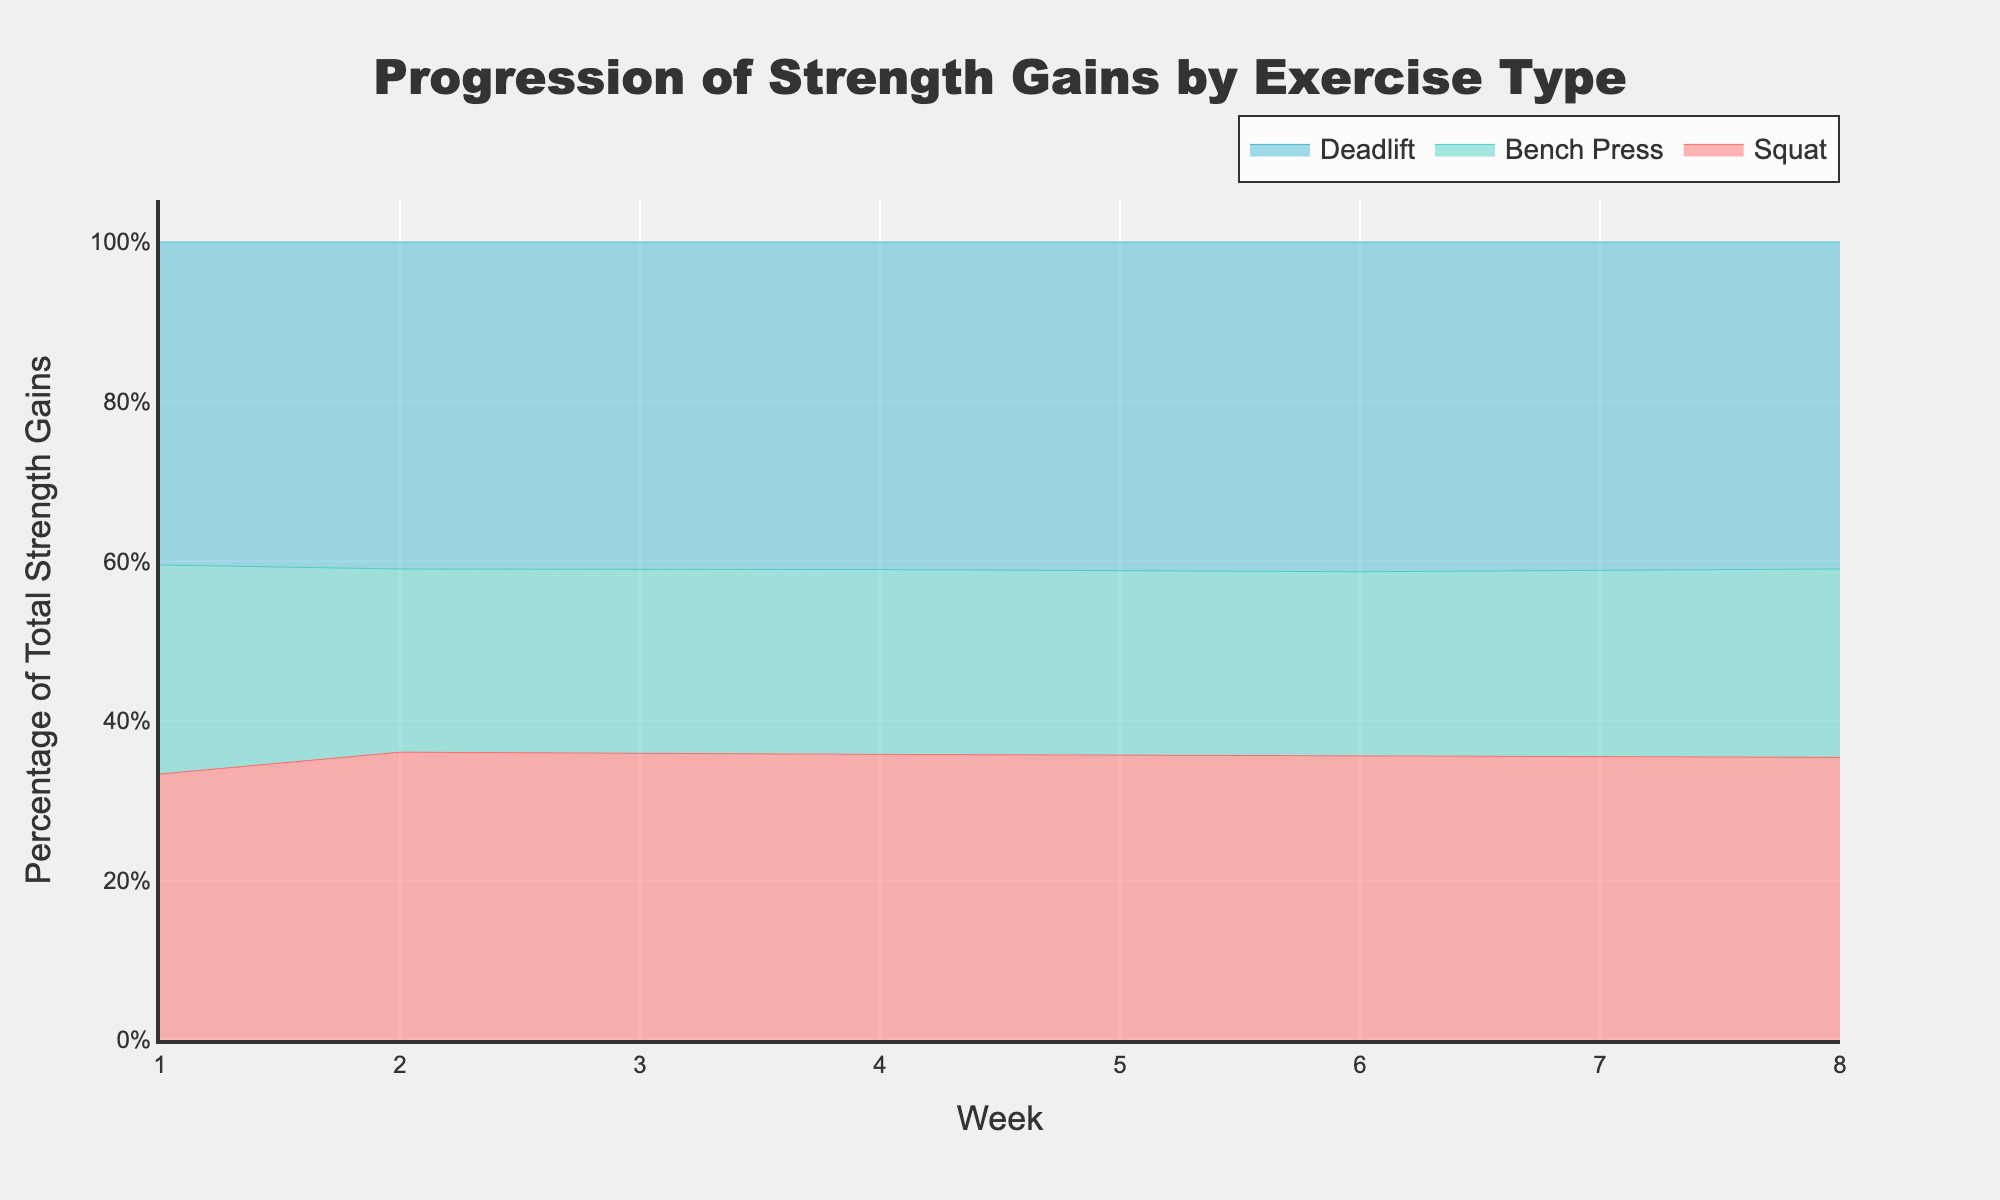What is the title of the chart? The title of the chart is typically displayed at the top center of the figure. In this case, the title is clearly indicated as "Progression of Strength Gains by Exercise Type."
Answer: Progression of Strength Gains by Exercise Type Which exercise type shows the largest percentage of strength gains in Week 8? Look at the area takes up by each exercise in Week 8. Squat, Deadlift, and then Bench Press, based on their vertical order in the stack. The one with the largest colored area will show the highest percentage.
Answer: Deadlift Across the training duration, which exercise type consistently shows the smallest percentage of strength gains? Consistently observe the areas from Week 1 to Week 8. The smallest colored area for all weeks will represent the exercise type with the smallest gains across the training duration.
Answer: Bench Press From Week 4 to Week 6, how does the relative strength gain in Squat compare to Bench Press? Calculate the percentage gain for both Squat and Bench Press in Weeks 4 and 6. Squat shows a significant increase while the Bench Press increases more slowly.
Answer: Squat increases more than Bench Press How does the trend in Deadlift strength gains change from Week 1 to Week 8? Observe the area dedicated to Deadlift from Week 1 to Week 8. It consistently increases, reflecting growing strength gains.
Answer: Consistently increases During which week does Bench Press see the highest proportional gain? By inspecting the highest relative area for Bench Press from Week 1 to Week 8, it can be observed which week has the largest portion of the Bench Press area.
Answer: Week 8 What can you say about the trajectory of Squat gains over the weeks? Observe the Squat area from Week 1 to Week 8. It shows a steady increase, indicating an improvement in the exercise over time.
Answer: Steady increase Between Week 6 and Week 8, which exercise type shows the greatest relative increase in strength gains? Calculate the relative increase by comparing the areas of each exercise between Week 6 and Week 8. Deadlift shows the largest relative gain.
Answer: Deadlift What compositional differences can be observed between Week 2 and Week 4? Compare the area ratios for each exercise between Weeks 2 and 4. Squat and Deadlift increases significantly while Bench Press shows some improvements but less pronounced.
Answer: Squat and Deadlift grow, Bench Press less Considering the entire data range, which exercise shows the quickest initial gains? Look at the areas in the early weeks (Week 1 to Week 2). Squat and Deadlift increase more rapidly compared to Bench Press.
Answer: Squat and Deadlift 